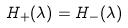<formula> <loc_0><loc_0><loc_500><loc_500>H _ { + } ( \lambda ) = H _ { - } ( \lambda )</formula> 